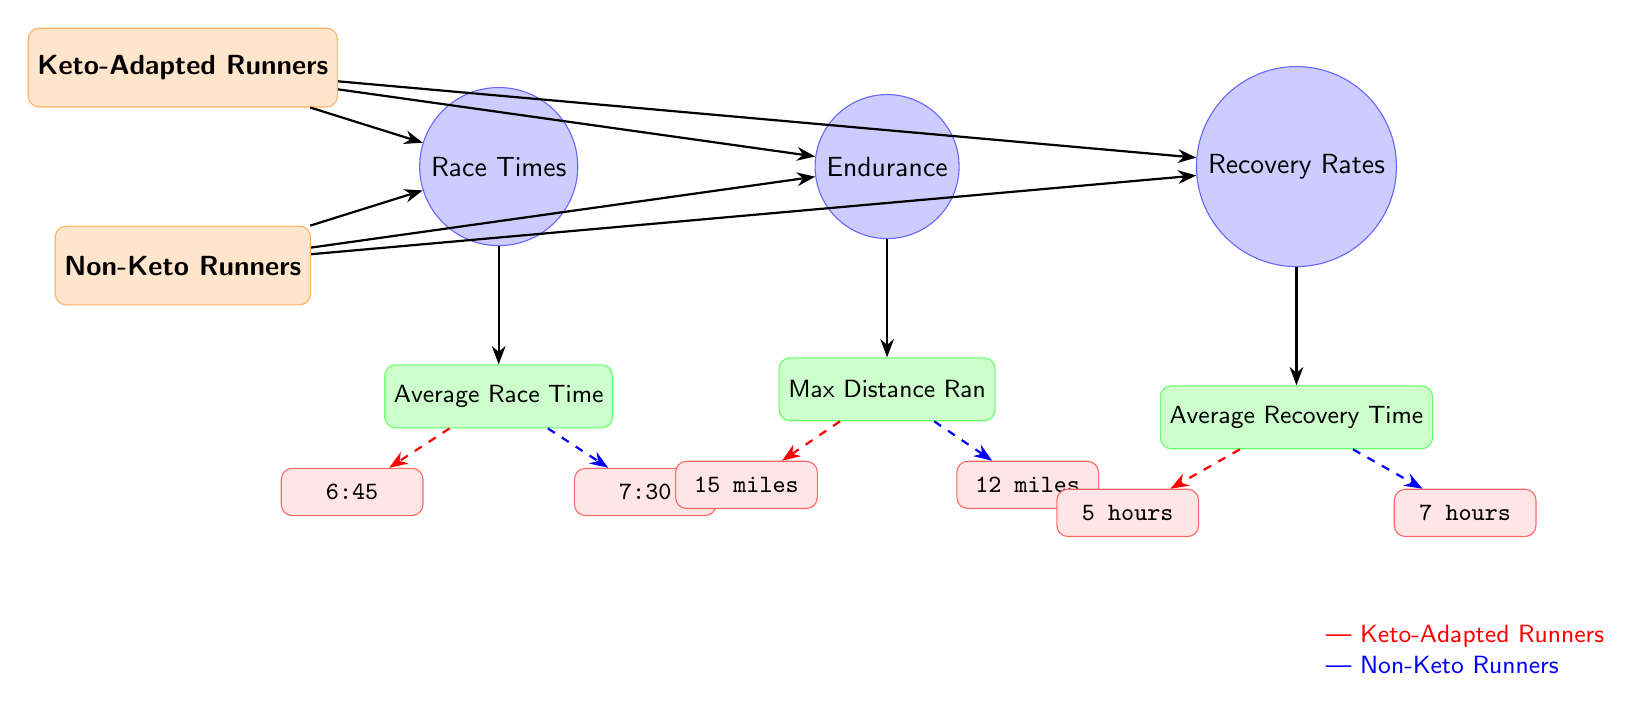What is the average race time for keto-adapted runners? The diagram shows a value node connected to the "Average Race Time" data node for keto-adapted runners. The value is indicated as "6:45".
Answer: 6:45 What is the maximum distance run by non-keto runners? The "Max Distance Ran" data node indicates the corresponding value for non-keto runners. This is shown as "12 miles".
Answer: 12 miles Which group has a shorter average recovery time? By examining the average recovery time values for both groups, the keto-adapted runners have "5 hours" and non-keto runners have "7 hours". Hence, keto-adapted runners have the shorter recovery time.
Answer: Keto-Adapted Runners What is the maximum distance run by keto-adapted runners? The "Max Distance Ran" data node specifies the maximum distance for keto-adapted runners, indicated as "15 miles".
Answer: 15 miles How much longer is the average race time for non-keto runners compared to keto-adapted runners? The average race time for non-keto runners is "7:30" and for keto-adapted runners, it is "6:45". To find the difference, I convert these times into minutes: 7:30 is 7.5 minutes, and 6:45 is 6.75 minutes. The difference is 7.5 - 6.75 = 0.75 minutes, or 45 seconds.
Answer: 45 seconds What are the two performance metrics compared in the diagram? The diagram highlights three metrics, but the question specifically asks for two. The performance metrics include "Race Times" and "Endurance".
Answer: Race Times, Endurance Which runner group demonstrates better overall performance across all metrics? By analyzing the values provided in the diagram for both groups, keto-adapted runners show faster average race times, greater maximal distance, and shorter recovery times compared to non-keto runners.
Answer: Keto-Adapted Runners 